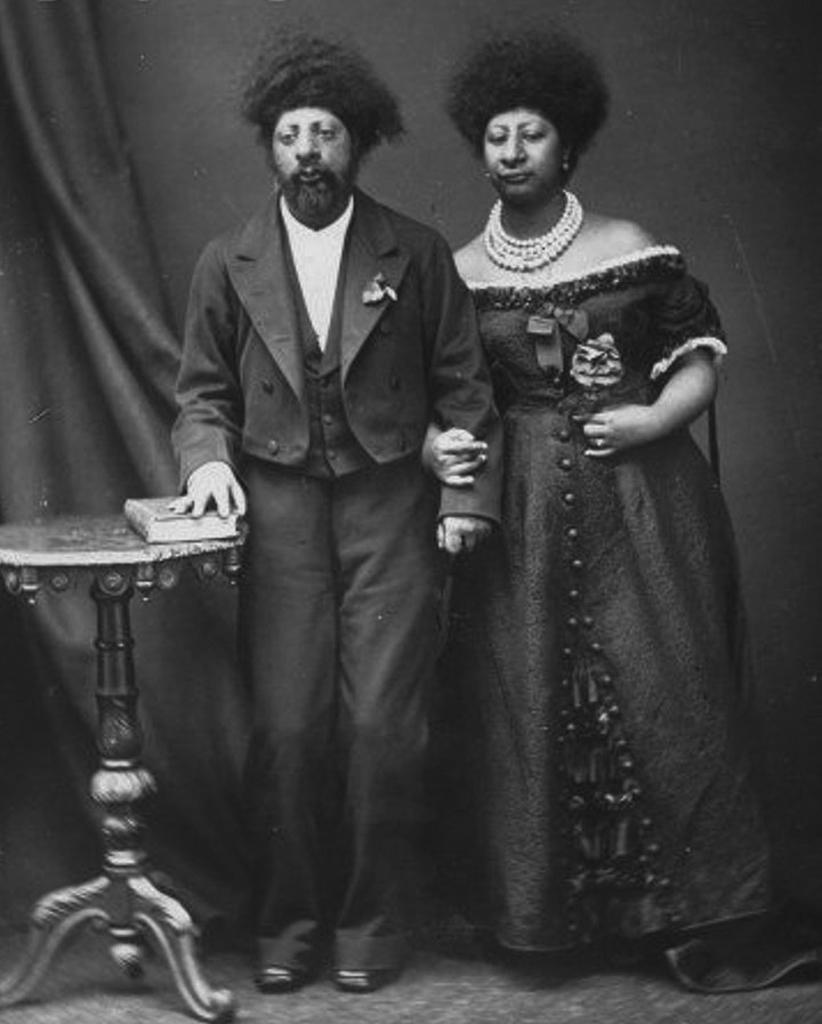Could you give a brief overview of what you see in this image? This is a black and white image. In this image we can see man and woman standing on the floor. On the left side of the image we can see table and book. In the background there is curtain. 